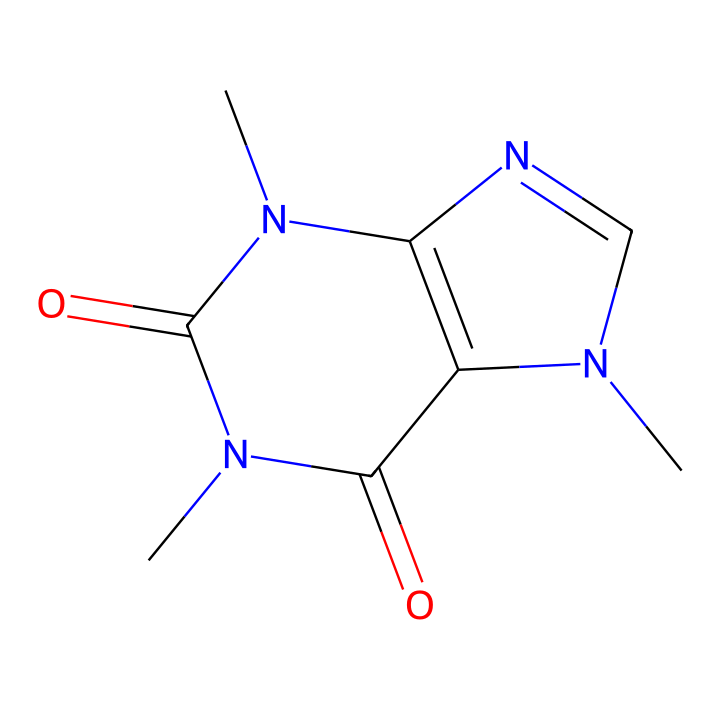What is the molecular formula of caffeine? To determine the molecular formula, we can break down the atoms in the SMILES representation: C represents carbon, N for nitrogen, and O for oxygen. Counting the atoms gives us: 8 carbons, 10 hydrogens, 4 nitrogens, and 2 oxygens, leading to the formula C8H10N4O2.
Answer: C8H10N4O2 How many nitrogen atoms are present in caffeine? The SMILES representation contains four occurrences of the letter N, which indicates the presence of four nitrogen atoms in the structure.
Answer: 4 What type of chemical compound is caffeine classified as? By examining its structure, which consists of a specific arrangement of nitrogen and carbon atoms, caffeine falls under the classification of alkaloids, commonly recognized for their physiological effects.
Answer: alkaloid How does the presence of carbonyl groups affect caffeine's properties? The carbonyl groups, indicated by the C=O linkages in the structure, contribute to the reactivity of the molecule and are key factors in its bitter taste, solubility, and ability to form hydrogen bonds with receptors in the body.
Answer: reactivity and solubility What is the total number of rings in the caffeine structure? Analyzing the SMILES representation, we can identify two fused rings present in the structure that define the overall shape of caffeine.
Answer: 2 What part of caffeine's structure is responsible for its stimulant effects? The xanthine base structure, which features multiple nitrogen atoms within the rings, is primarily responsible for the stimulant effects due to its interaction with adenosine receptors in the brain.
Answer: xanthine base structure 